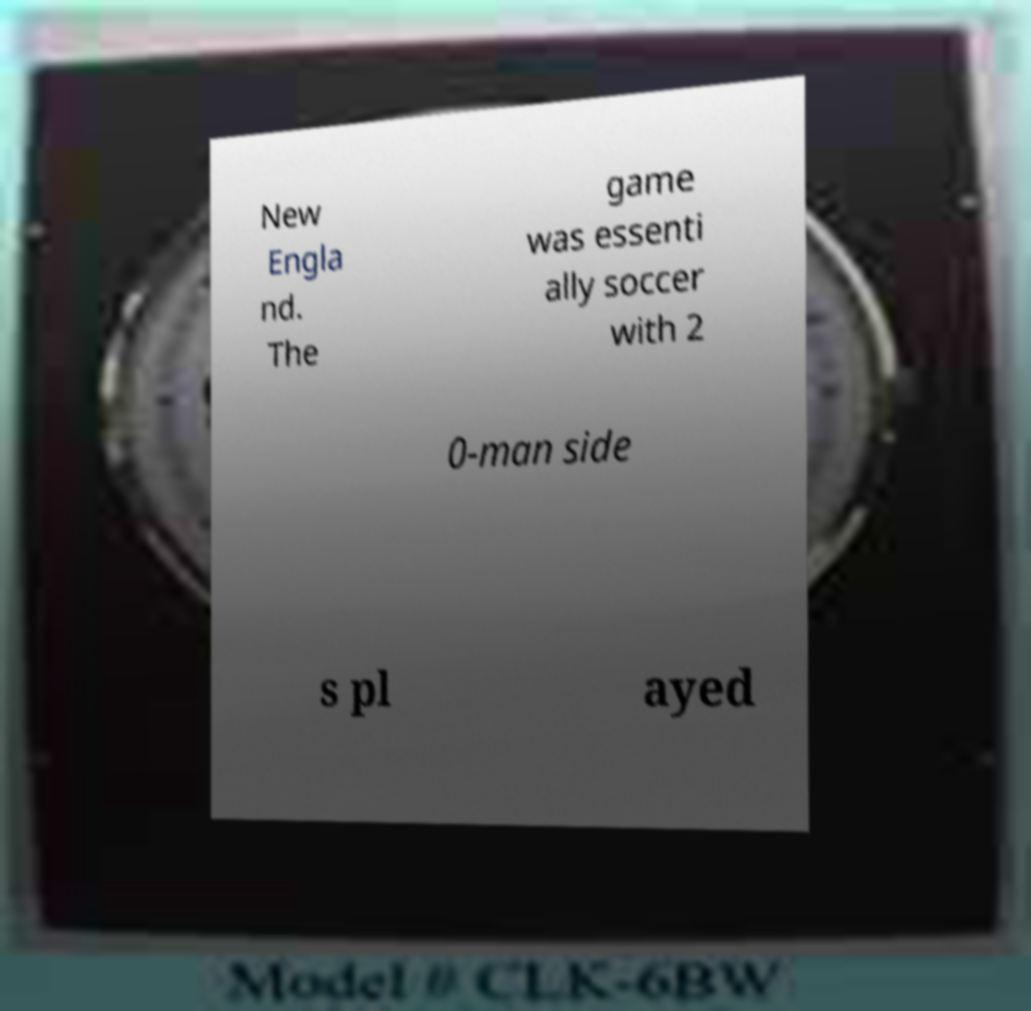Please identify and transcribe the text found in this image. New Engla nd. The game was essenti ally soccer with 2 0-man side s pl ayed 